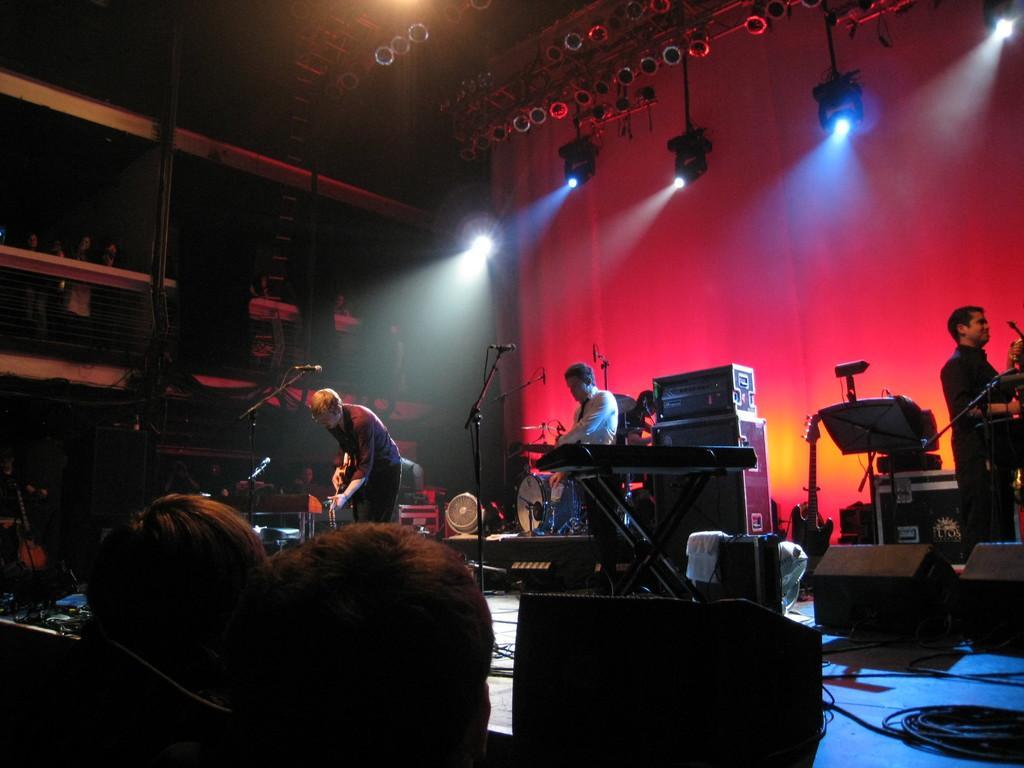Could you give a brief overview of what you see in this image? There are people standing on the stage and playing musical instruments in the middle of this image. We can see people at the bottom of this image and there is a wall in the background. There are lights at the top of this image. 